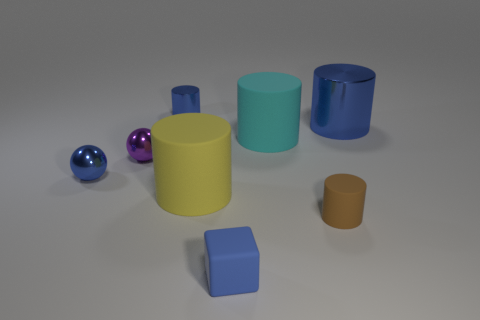Subtract all cyan cylinders. How many cylinders are left? 4 Subtract all yellow rubber cylinders. How many cylinders are left? 4 Subtract all red cylinders. Subtract all purple cubes. How many cylinders are left? 5 Add 1 large blue things. How many objects exist? 9 Subtract all cylinders. How many objects are left? 3 Add 4 yellow matte balls. How many yellow matte balls exist? 4 Subtract 0 gray balls. How many objects are left? 8 Subtract all small purple shiny balls. Subtract all metal cylinders. How many objects are left? 5 Add 1 big yellow rubber things. How many big yellow rubber things are left? 2 